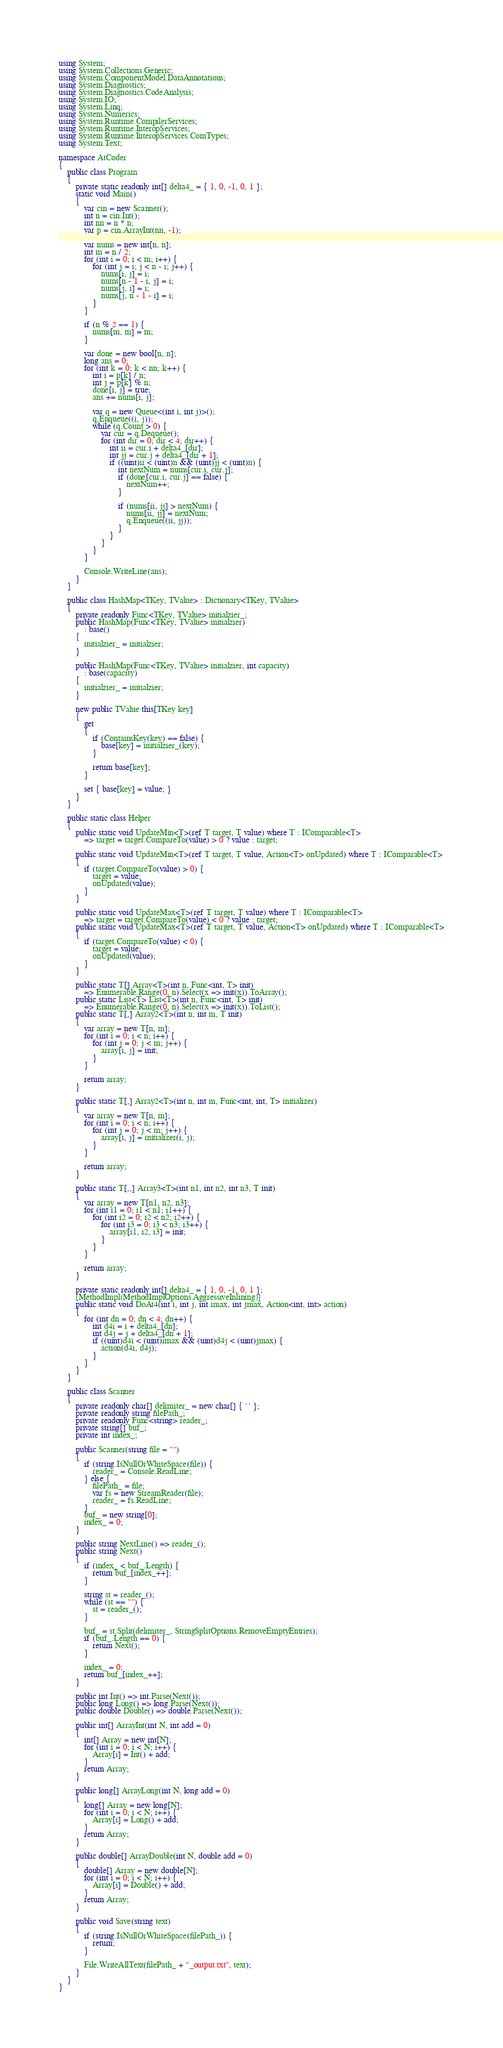<code> <loc_0><loc_0><loc_500><loc_500><_C#_>using System;
using System.Collections.Generic;
using System.ComponentModel.DataAnnotations;
using System.Diagnostics;
using System.Diagnostics.CodeAnalysis;
using System.IO;
using System.Linq;
using System.Numerics;
using System.Runtime.CompilerServices;
using System.Runtime.InteropServices;
using System.Runtime.InteropServices.ComTypes;
using System.Text;

namespace AtCoder
{
	public class Program
	{
		private static readonly int[] delta4_ = { 1, 0, -1, 0, 1 };
		static void Main()
		{
			var cin = new Scanner();
			int n = cin.Int();
			int nn = n * n;
			var p = cin.ArrayInt(nn, -1);

			var nums = new int[n, n];
			int m = n / 2;
			for (int i = 0; i < m; i++) {
				for (int j = i; j < n - i; j++) {
					nums[i, j] = i;
					nums[n - 1 - i, j] = i;
					nums[j, i] = i;
					nums[j, n - 1 - i] = i;
				}
			}

			if (n % 2 == 1) {
				nums[m, m] = m;
			}

			var done = new bool[n, n];
			long ans = 0;
			for (int k = 0; k < nn; k++) {
				int i = p[k] / n;
				int j = p[k] % n;
				done[i, j] = true;
				ans += nums[i, j];

				var q = new Queue<(int i, int j)>();
				q.Enqueue((i, j));
				while (q.Count > 0) {
					var cur = q.Dequeue();
					for (int dir = 0; dir < 4; dir++) {
						int ii = cur.i + delta4_[dir];
						int jj = cur.j + delta4_[dir + 1];
						if ((uint)ii < (uint)n && (uint)jj < (uint)n) {
							int nextNum = nums[cur.i, cur.j];
							if (done[cur.i, cur.j] == false) {
								nextNum++;
							}

							if (nums[ii, jj] > nextNum) {
								nums[ii, jj] = nextNum;
								q.Enqueue((ii, jj));
							}
						}
					}
				}
			}

			Console.WriteLine(ans);
		}
	}

	public class HashMap<TKey, TValue> : Dictionary<TKey, TValue>
	{
		private readonly Func<TKey, TValue> initialzier_;
		public HashMap(Func<TKey, TValue> initialzier)
			: base()
		{
			initialzier_ = initialzier;
		}

		public HashMap(Func<TKey, TValue> initialzier, int capacity)
			: base(capacity)
		{
			initialzier_ = initialzier;
		}

		new public TValue this[TKey key]
		{
			get
			{
				if (ContainsKey(key) == false) {
					base[key] = initialzier_(key);
				}

				return base[key];
			}

			set { base[key] = value; }
		}
	}

	public static class Helper
	{
		public static void UpdateMin<T>(ref T target, T value) where T : IComparable<T>
			=> target = target.CompareTo(value) > 0 ? value : target;

		public static void UpdateMin<T>(ref T target, T value, Action<T> onUpdated) where T : IComparable<T>
		{
			if (target.CompareTo(value) > 0) {
				target = value;
				onUpdated(value);
			}
		}

		public static void UpdateMax<T>(ref T target, T value) where T : IComparable<T>
			=> target = target.CompareTo(value) < 0 ? value : target;
		public static void UpdateMax<T>(ref T target, T value, Action<T> onUpdated) where T : IComparable<T>
		{
			if (target.CompareTo(value) < 0) {
				target = value;
				onUpdated(value);
			}
		}

		public static T[] Array<T>(int n, Func<int, T> init)
			=> Enumerable.Range(0, n).Select(x => init(x)).ToArray();
		public static List<T> List<T>(int n, Func<int, T> init)
			=> Enumerable.Range(0, n).Select(x => init(x)).ToList();
		public static T[,] Array2<T>(int n, int m, T init)
		{
			var array = new T[n, m];
			for (int i = 0; i < n; i++) {
				for (int j = 0; j < m; j++) {
					array[i, j] = init;
				}
			}

			return array;
		}

		public static T[,] Array2<T>(int n, int m, Func<int, int, T> initializer)
		{
			var array = new T[n, m];
			for (int i = 0; i < n; i++) {
				for (int j = 0; j < m; j++) {
					array[i, j] = initializer(i, j);
				}
			}

			return array;
		}

		public static T[,,] Array3<T>(int n1, int n2, int n3, T init)
		{
			var array = new T[n1, n2, n3];
			for (int i1 = 0; i1 < n1; i1++) {
				for (int i2 = 0; i2 < n2; i2++) {
					for (int i3 = 0; i3 < n3; i3++) {
						array[i1, i2, i3] = init;
					}
				}
			}

			return array;
		}

		private static readonly int[] delta4_ = { 1, 0, -1, 0, 1 };
		[MethodImpl(MethodImplOptions.AggressiveInlining)]
		public static void DoAt4(int i, int j, int imax, int jmax, Action<int, int> action)
		{
			for (int dn = 0; dn < 4; dn++) {
				int d4i = i + delta4_[dn];
				int d4j = j + delta4_[dn + 1];
				if ((uint)d4i < (uint)imax && (uint)d4j < (uint)jmax) {
					action(d4i, d4j);
				}
			}
		}
	}

	public class Scanner
	{
		private readonly char[] delimiter_ = new char[] { ' ' };
		private readonly string filePath_;
		private readonly Func<string> reader_;
		private string[] buf_;
		private int index_;

		public Scanner(string file = "")
		{
			if (string.IsNullOrWhiteSpace(file)) {
				reader_ = Console.ReadLine;
			} else {
				filePath_ = file;
				var fs = new StreamReader(file);
				reader_ = fs.ReadLine;
			}
			buf_ = new string[0];
			index_ = 0;
		}

		public string NextLine() => reader_();
		public string Next()
		{
			if (index_ < buf_.Length) {
				return buf_[index_++];
			}

			string st = reader_();
			while (st == "") {
				st = reader_();
			}

			buf_ = st.Split(delimiter_, StringSplitOptions.RemoveEmptyEntries);
			if (buf_.Length == 0) {
				return Next();
			}

			index_ = 0;
			return buf_[index_++];
		}

		public int Int() => int.Parse(Next());
		public long Long() => long.Parse(Next());
		public double Double() => double.Parse(Next());

		public int[] ArrayInt(int N, int add = 0)
		{
			int[] Array = new int[N];
			for (int i = 0; i < N; i++) {
				Array[i] = Int() + add;
			}
			return Array;
		}

		public long[] ArrayLong(int N, long add = 0)
		{
			long[] Array = new long[N];
			for (int i = 0; i < N; i++) {
				Array[i] = Long() + add;
			}
			return Array;
		}

		public double[] ArrayDouble(int N, double add = 0)
		{
			double[] Array = new double[N];
			for (int i = 0; i < N; i++) {
				Array[i] = Double() + add;
			}
			return Array;
		}

		public void Save(string text)
		{
			if (string.IsNullOrWhiteSpace(filePath_)) {
				return;
			}

			File.WriteAllText(filePath_ + "_output.txt", text);
		}
	}
}
</code> 